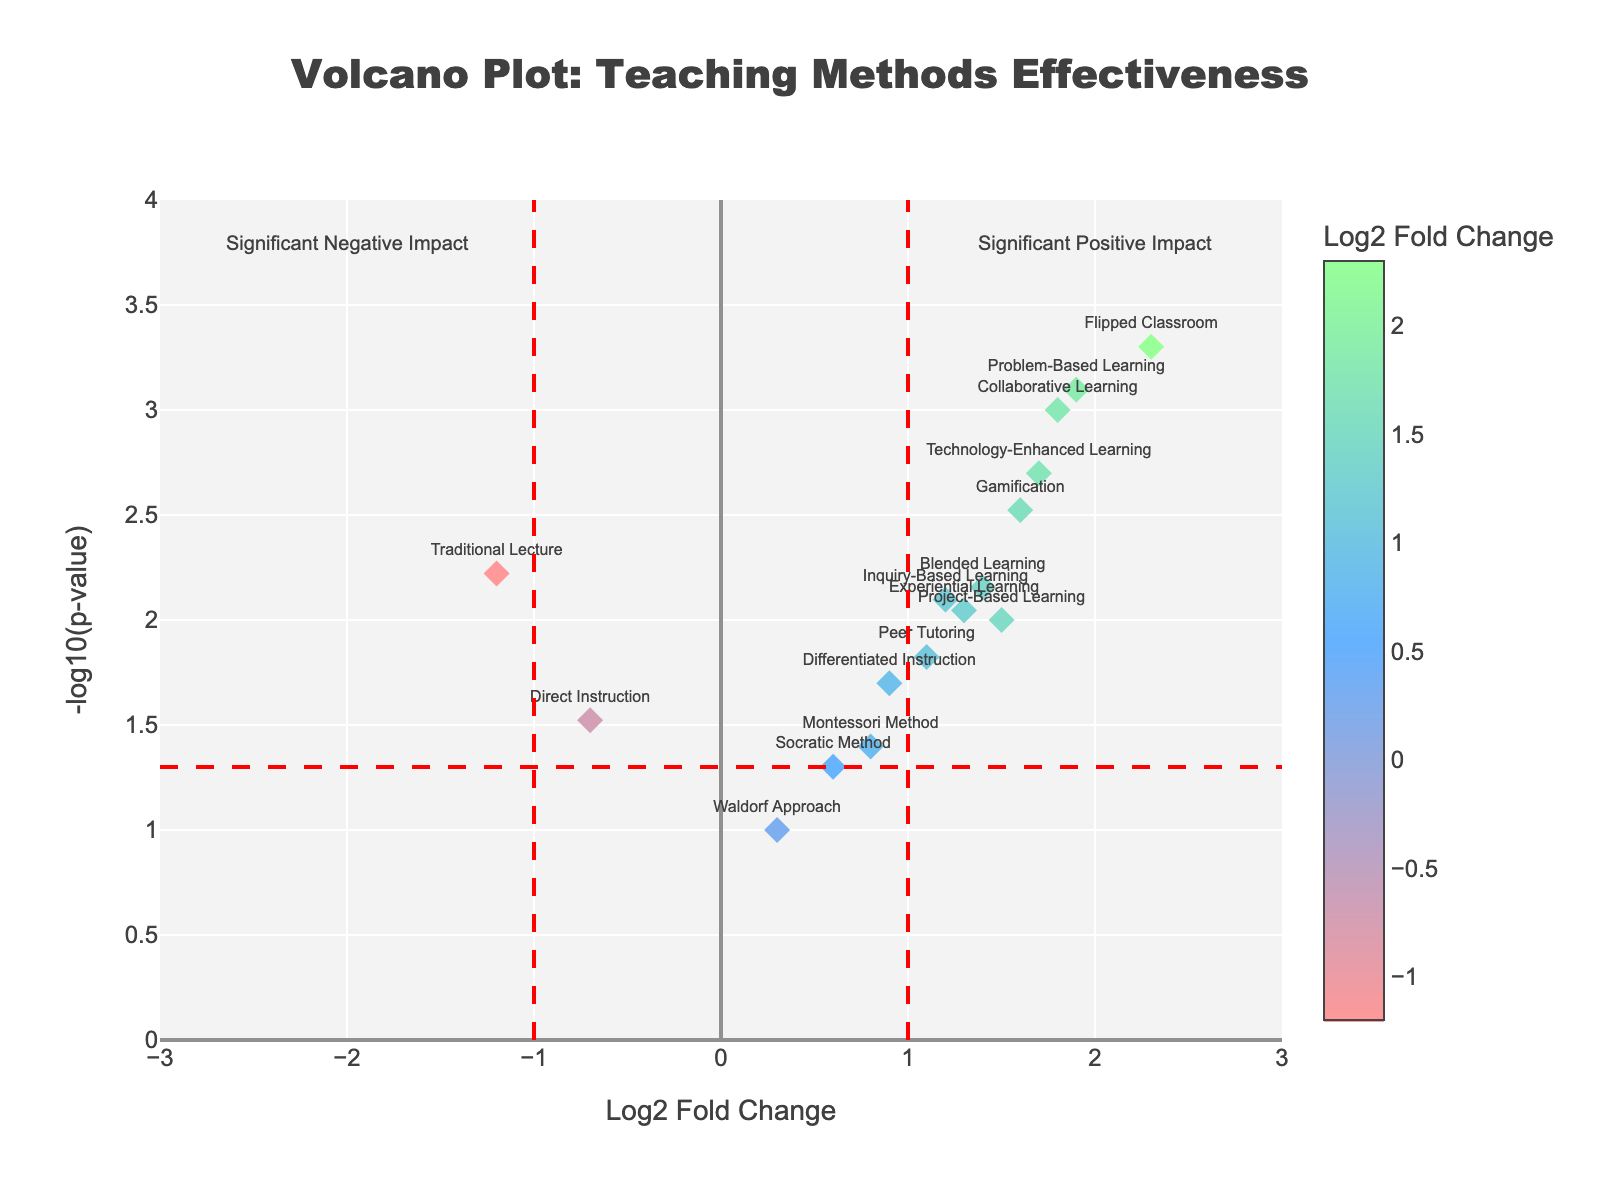What is the title of the plot? The title of the plot is typically located at the top center and provides an overview of what the plot represents. It helps to quickly identify the purpose of the figure.
Answer: Volcano Plot: Teaching Methods Effectiveness How many teaching methods show a significant positive impact? We consider significance lines at Log2 Fold Change of 1 (x-axis) and -log10(p-value) of 1.3 (y-axis). Methods above both thresholds are significantly positive. By counting, we see: Collaborative Learning, Flipped Classroom, Gamification, Problem-Based Learning, Technology-Enhanced Learning.
Answer: 5 Which teaching method has the highest Log2 Fold Change? By observing the x-axis which represents Log2 Fold Change, we identify the highest positive value. The Flipped Classroom method stands out with a value of 2.3.
Answer: Flipped Classroom What does the red dashed vertical line at Log2 Fold Change of 1 signify? The threshold lines at Log2 Fold Change values of 1 and -1 mark the cutoff for significant positive and negative impact. Any method beyond these lines is considered to have a significant impact.
Answer: Significance threshold for positive impact Are there any methods with a significant negative impact on student performance? We consider methods falling left of the red dashed line at -1 along the Log2 Fold Change axis and above the significance threshold of -log10(p-value) = 1.3. Traditional Lecture is the only method meeting these criteria.
Answer: Yes, Traditional Lecture Which method has the lowest P-value? By focusing on the y-axis which features -log10(p-value) and identifying the method with the highest y-value, it can be seen that the Flipped Classroom has the highest -log10(p-value), implying the lowest P-value.
Answer: Flipped Classroom What is the Log2 Fold Change and p-value for Project-Based Learning? Locate the point labeled 'Project-Based Learning' and reference the hover text or x and y values: Log2 Fold Change is 1.5 and p-value is 0.01.
Answer: Log2FC: 1.5, p-value: 0.01 